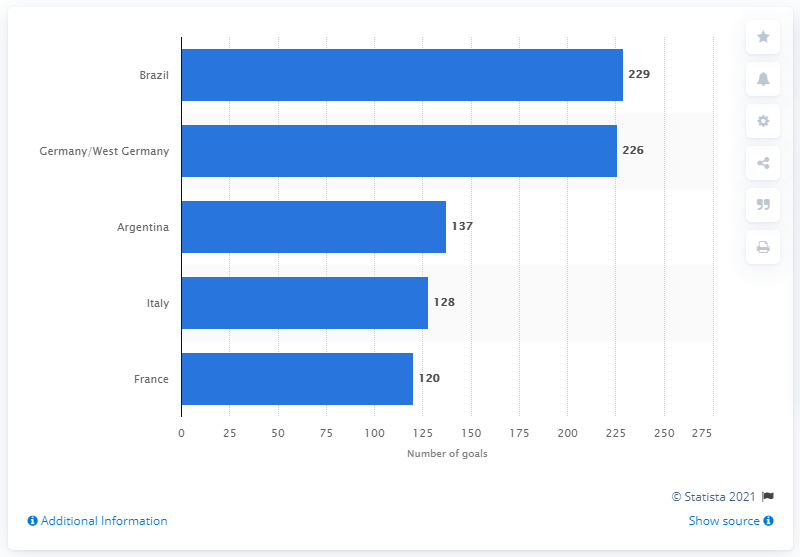Which country has the second highest number of goals and how does this reflect in their World Cup success? Germany, including its former designation as West Germany, has the second highest number of goals, as shown on the chart. This reflects their success in the World Cup, where they have been consistently strong competitors, winning the tournament several times and often progressing to the latter stages. The goal tally is testament to their historical strength and championship pedigree. How might this data influence the perception of a country's football team globally? High goal counts and positive World Cup performance can greatly influence a country's reputation in the football world. It elevates the team's status, making them more respected and feared opponents. It also enhances the country's appeal in terms of attracting talented players, coaches, and investment in football infrastructure. Moreover, it boosts national pride and can inspire younger generations to take up the sport. 